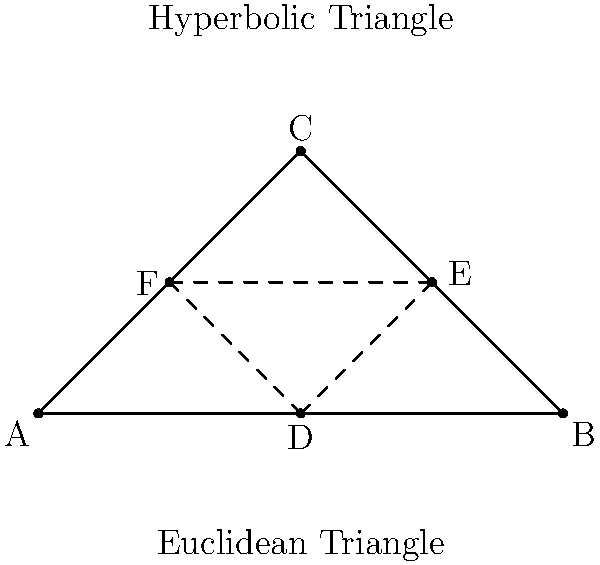In the context of non-Euclidean geometry, specifically on a hyperbolic plane, what would be the sum of the interior angles of the triangle ABC, assuming the same triangle configuration as shown in the Euclidean plane above? To understand this concept, let's follow these steps:

1) In Euclidean geometry, the sum of the interior angles of any triangle is always 180°.

2) However, in hyperbolic geometry, this rule doesn't hold true. The sum of the interior angles of a triangle is always less than 180°.

3) In hyperbolic geometry, parallel lines behave differently. They diverge from each other, creating what's known as "angle defect".

4) The angle defect is directly proportional to the area of the triangle. The larger the triangle, the greater the angle defect.

5) The formula for the sum of interior angles in a hyperbolic triangle is:

   $$ \alpha + \beta + \gamma = \pi - A $$

   Where $\alpha$, $\beta$, and $\gamma$ are the interior angles, $\pi$ is 180° in radians, and $A$ is the area of the triangle in the hyperbolic plane.

6) The area $A$ is always positive in hyperbolic geometry, so the sum of the angles is always less than $\pi$ (180°).

7) The exact sum would depend on the specific area of the triangle in the hyperbolic plane, which is not provided in the question.

This concept challenges our Euclidean intuition and demonstrates how geometric properties can fundamentally change in different spatial models, a key aspect of non-Euclidean geometry.
Answer: Less than 180° 